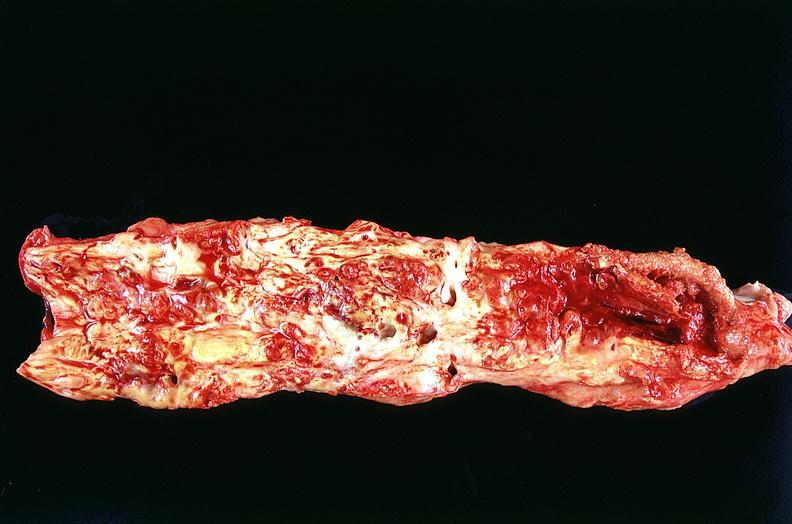s vasculature present?
Answer the question using a single word or phrase. Yes 